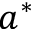Convert formula to latex. <formula><loc_0><loc_0><loc_500><loc_500>a ^ { * }</formula> 